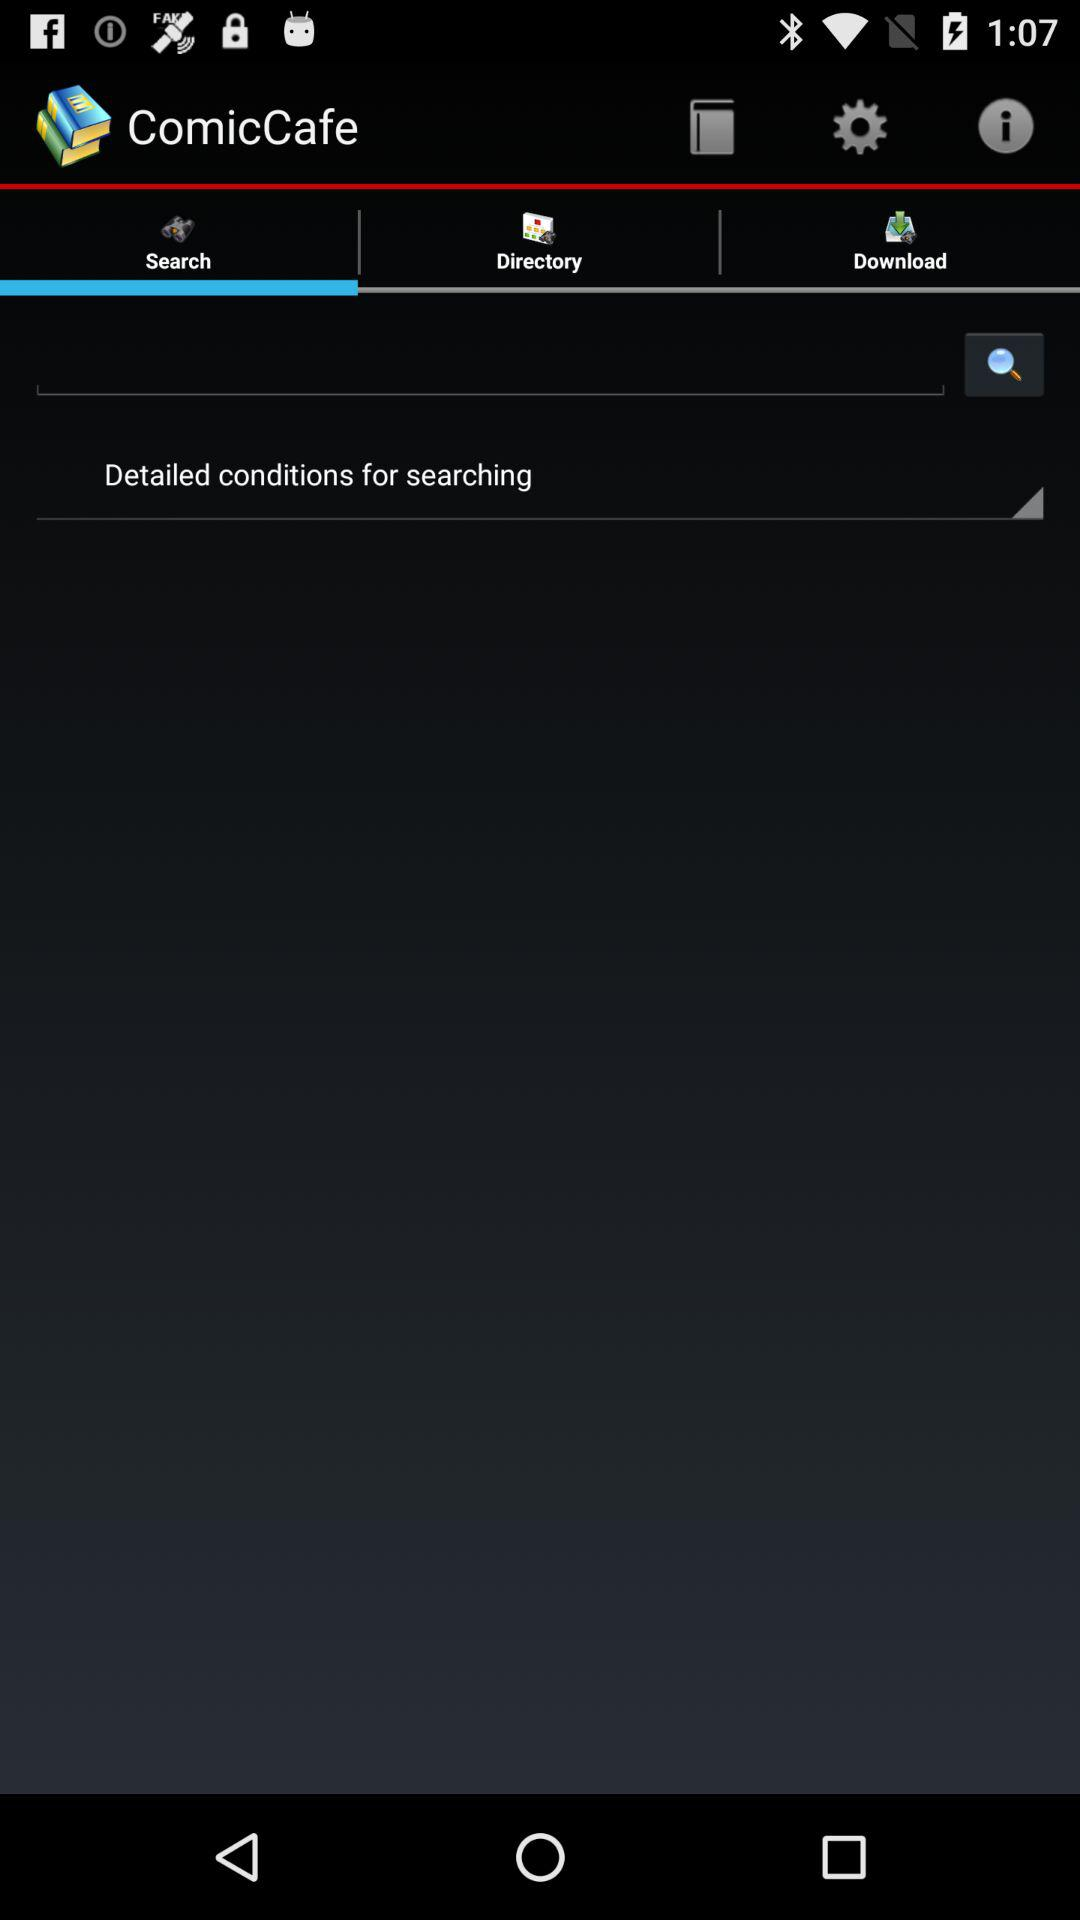What is the application name? The application name is "ComicCafe". 